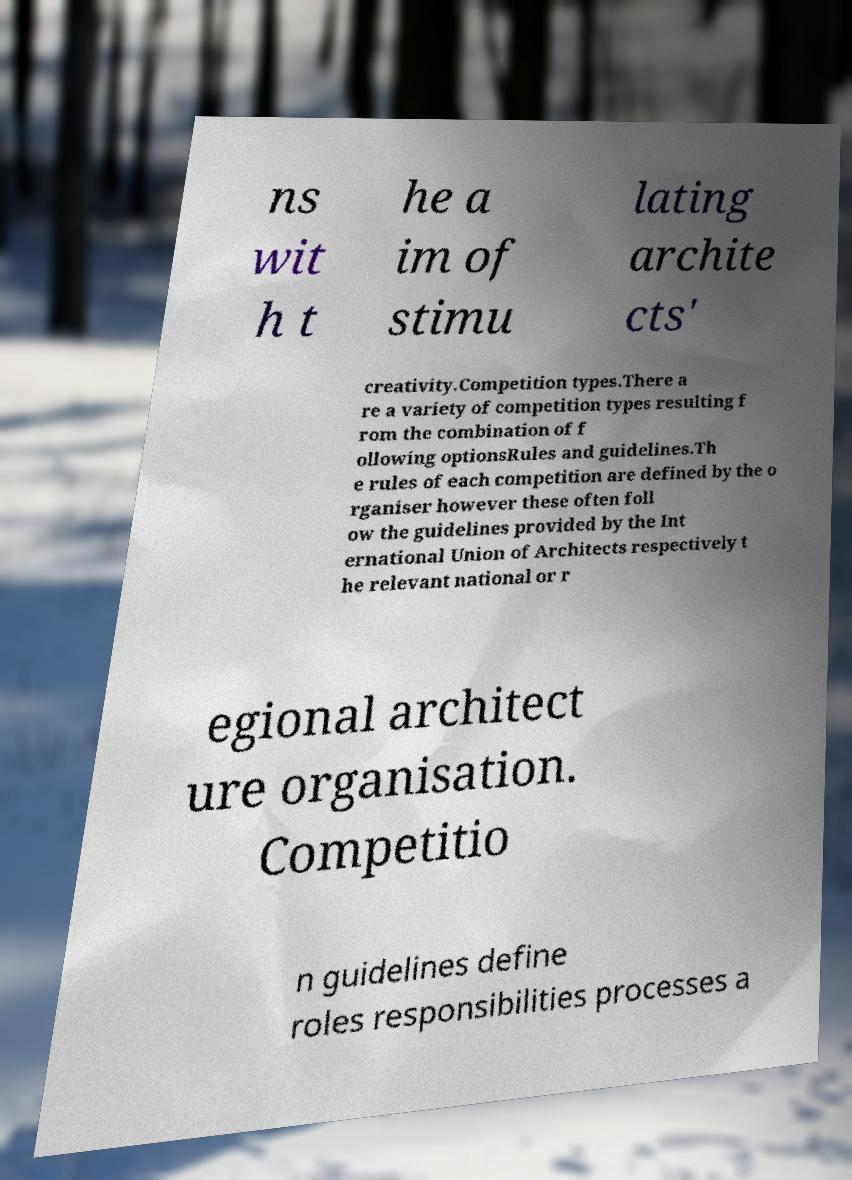Can you accurately transcribe the text from the provided image for me? ns wit h t he a im of stimu lating archite cts' creativity.Competition types.There a re a variety of competition types resulting f rom the combination of f ollowing optionsRules and guidelines.Th e rules of each competition are defined by the o rganiser however these often foll ow the guidelines provided by the Int ernational Union of Architects respectively t he relevant national or r egional architect ure organisation. Competitio n guidelines define roles responsibilities processes a 